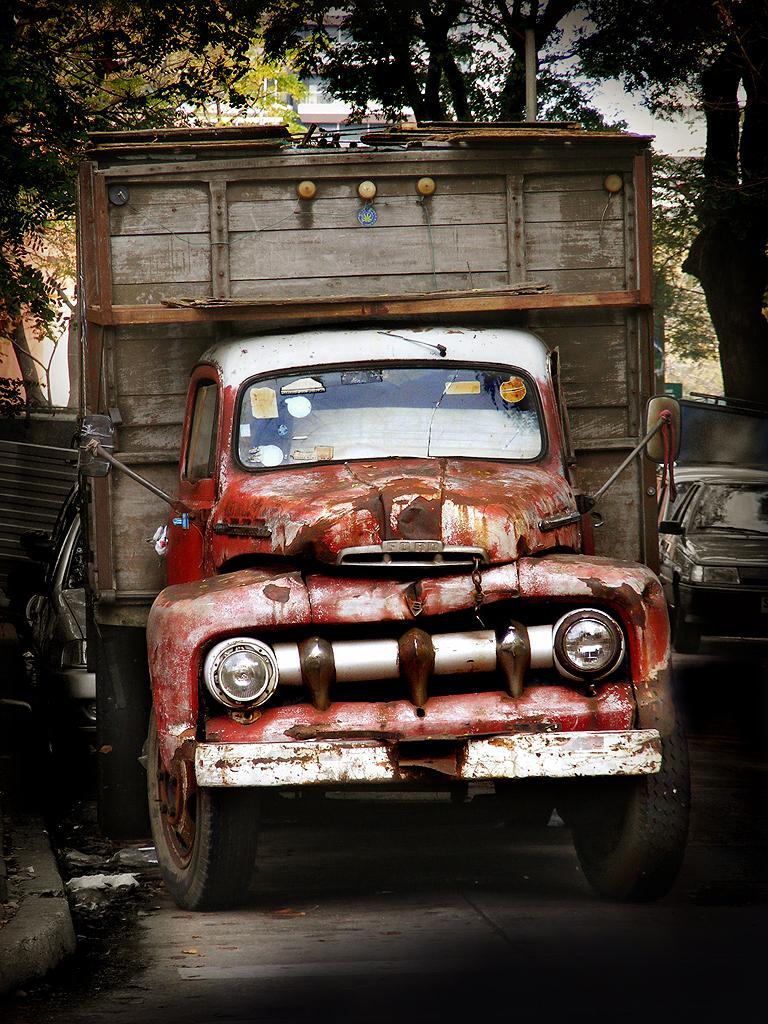Describe this image in one or two sentences. This picture shows a truck and we see trees and few cars parked on the back and on the side of the truck and we see a cloudy Sky. 